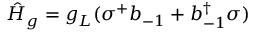Convert formula to latex. <formula><loc_0><loc_0><loc_500><loc_500>\hat { H } _ { g } = g _ { L } ( \sigma ^ { + } b _ { - 1 } + b _ { - 1 } ^ { \dagger } \sigma )</formula> 